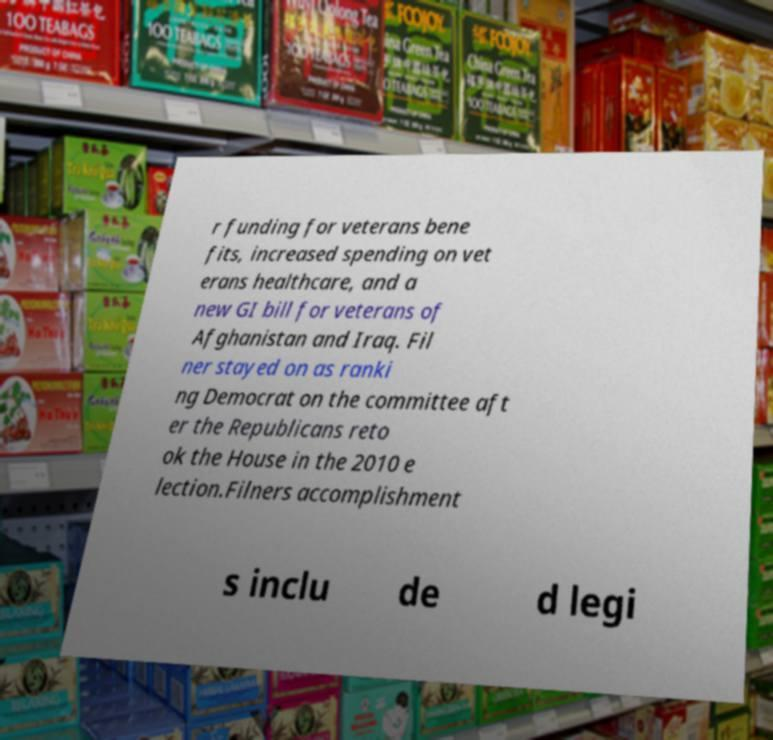Can you read and provide the text displayed in the image?This photo seems to have some interesting text. Can you extract and type it out for me? r funding for veterans bene fits, increased spending on vet erans healthcare, and a new GI bill for veterans of Afghanistan and Iraq. Fil ner stayed on as ranki ng Democrat on the committee aft er the Republicans reto ok the House in the 2010 e lection.Filners accomplishment s inclu de d legi 